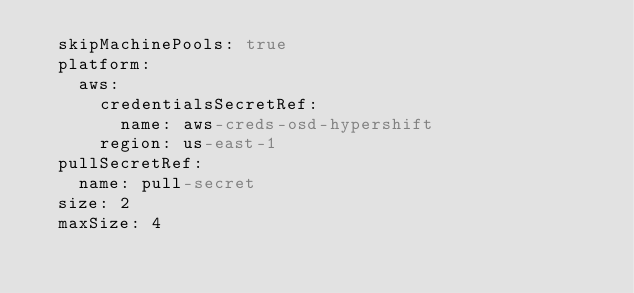Convert code to text. <code><loc_0><loc_0><loc_500><loc_500><_YAML_>  skipMachinePools: true
  platform:
    aws:
      credentialsSecretRef:
        name: aws-creds-osd-hypershift
      region: us-east-1
  pullSecretRef:
    name: pull-secret
  size: 2
  maxSize: 4
</code> 